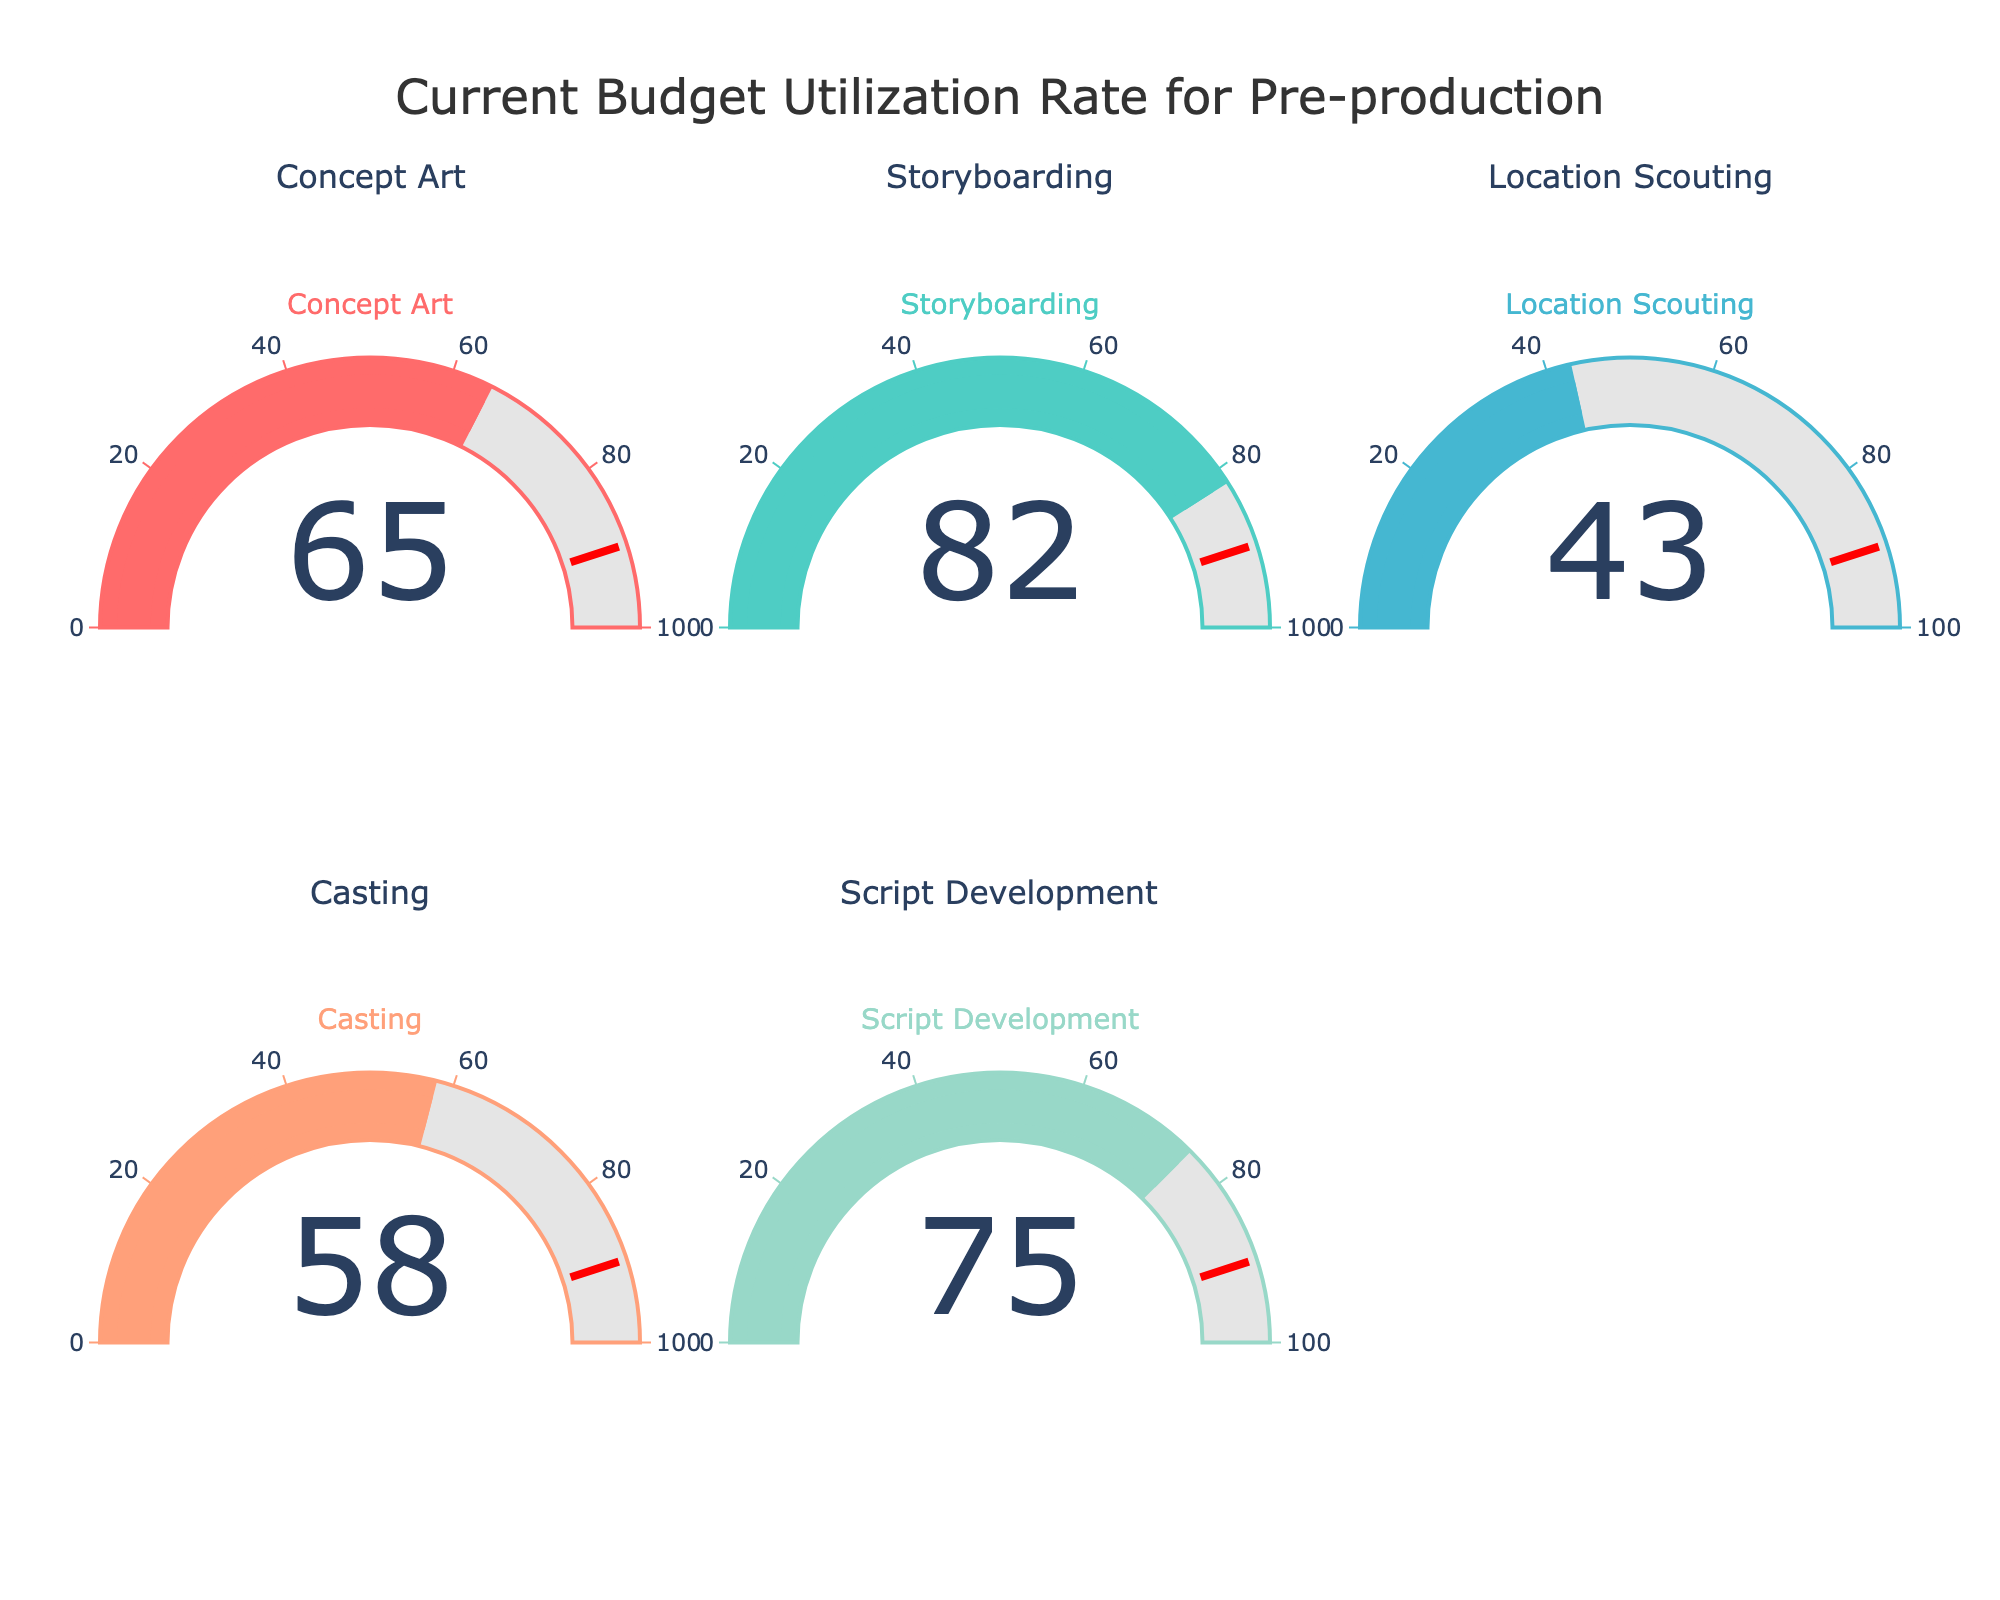What is the title of the figure? The title is usually at the top of the figure and is prominently displayed. In this case, it reads "Current Budget Utilization Rate for Pre-production."
Answer: Current Budget Utilization Rate for Pre-production How many categories are displayed in the figure? By counting the number of gauges or subplots, we can determine how many categories are shown. There are five categories: Concept Art, Storyboarding, Location Scouting, Casting, and Script Development.
Answer: Five Which category has the highest budget utilization rate? By looking at the values displayed on each gauge, we can identify the highest one. The maximum value is 82 for Storyboarding.
Answer: Storyboarding What is the difference in budget utilization between Casting and Location Scouting? Subtract the budget utilization rate of Location Scouting (43) from Casting (58), resulting in 58 - 43.
Answer: 15 Which category has a budget utilization rate closest to 70? By comparing all the values, Script Development (75) is the closest to 70.
Answer: Script Development What are the colors used for the gauges in the figure? Each gauge has a uniquely colored bar and border. The colors used are red for Concept Art, greenish-blue for Storyboarding, blue for Location Scouting, orange for Casting, and mint green for Script Development.
Answer: Red, Greenish-blue, Blue, Orange, Mint Green Is there any category with a budget utilization lower than 50%? Checking all the values, Location Scouting has a budget utilization of 43%, which is below 50%.
Answer: Location Scouting What is the average budget utilization rate across all categories? Adding all the utilization rates (65 + 82 + 43 + 58 + 75) and dividing by the number of categories (5), we get (65 + 82 + 43 + 58 + 75) / 5 = 323 / 5 = 64.6.
Answer: 64.6 Among the categories, which exceeds the utilization threshold of 90? By observing the thresholds marked on each gauge, none of the categories have a utilization rate exceeding 90.
Answer: None What is the sum of the utilization rates for Concept Art, Storyboarding, and Script Development? Adding the values for these categories, we have 65 (Concept Art) + 82 (Storyboarding) + 75 (Script Development) = 222.
Answer: 222 